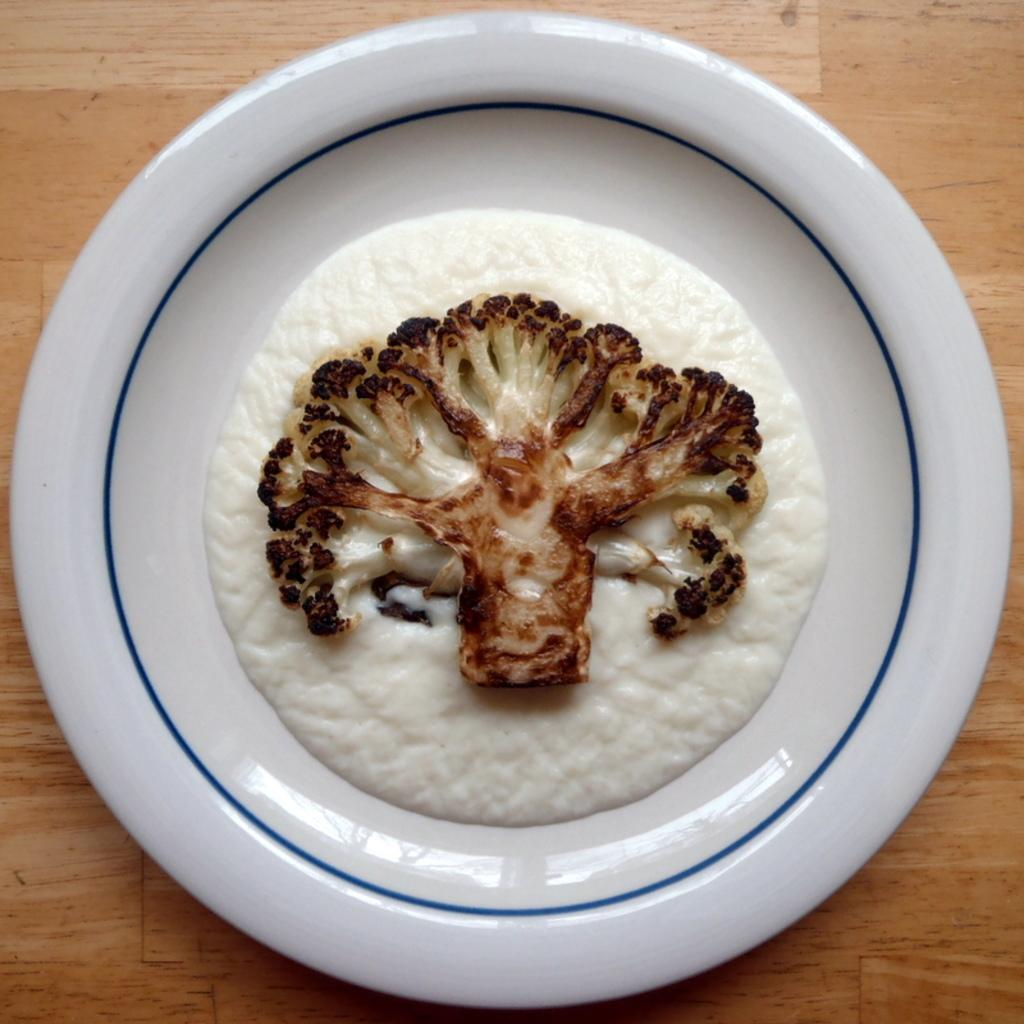What is present in the image? There is food in the image. What can you tell about the plate the food is on? The food is on a white color plate. What is the surface beneath the plate? The plate is on a brown color surface. What is the opinion of the food in the image? The image does not convey any opinions about the food; it simply shows the food on a plate. 